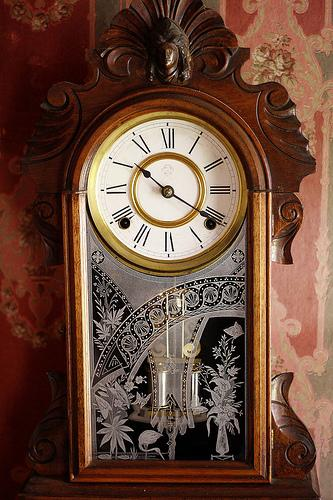In your own words, explain the details of the image, highlighting the central object. This image showcases an elegantly crafted wooden clock, adorned with Roman numeral face, intricate carvings, and beautiful glass etchings. Provide a brief description of the main object in the image. A brown wooden clock with Roman numerals on its face and intricate carvings. Mention the type of time display used in the clock and its embellishment. The clock has a traditional face with Roman numerals and decorative carvings. Describe the wallpaper and its design in the image. The wallpaper is red and pink with flower patterns and decorative swirls. Describe any animal or floral motif present in the image. The image features a stork etched in glass and flowers in a vase etched in glass too. Provide an overview of the central object in the image and its design elements. The image displays a wooden clock decorated with detailed carvings, a face with Roman numerals, and artwork on its glass panels. Explain the unique features of the image, focusing on the central object. The image showcases a wooden clock with intricate carving, a Roman numeral face, and etched glass with designs. State the primary components of the clock shown in the image. A wooden clock, Roman numerals, carved designs, and etched glass encasings. Summarize the key design elements seen on the glass components of the clock. The clock's glass features white designs including a stork, flowers in a vase, and a plant. List the aspects that make the clock in the image unique. Wooden frame, carving, Roman numerals, and etched glass designs. 